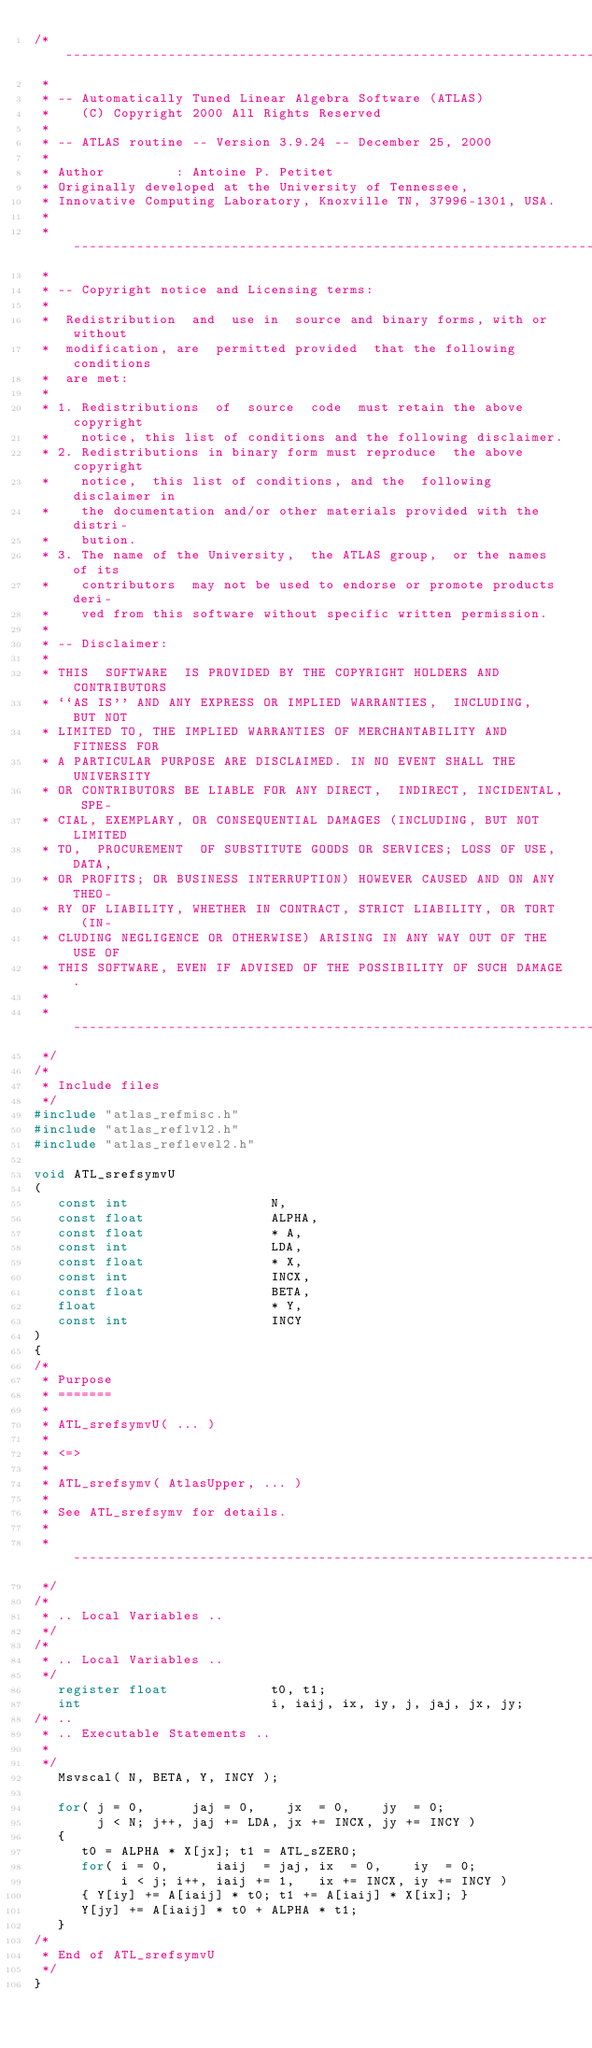Convert code to text. <code><loc_0><loc_0><loc_500><loc_500><_C_>/* ---------------------------------------------------------------------
 *
 * -- Automatically Tuned Linear Algebra Software (ATLAS)
 *    (C) Copyright 2000 All Rights Reserved
 *
 * -- ATLAS routine -- Version 3.9.24 -- December 25, 2000
 *
 * Author         : Antoine P. Petitet
 * Originally developed at the University of Tennessee,
 * Innovative Computing Laboratory, Knoxville TN, 37996-1301, USA.
 *
 * ---------------------------------------------------------------------
 *
 * -- Copyright notice and Licensing terms:
 *
 *  Redistribution  and  use in  source and binary forms, with or without
 *  modification, are  permitted provided  that the following  conditions
 *  are met:
 *
 * 1. Redistributions  of  source  code  must retain the above copyright
 *    notice, this list of conditions and the following disclaimer.
 * 2. Redistributions in binary form must reproduce  the above copyright
 *    notice,  this list of conditions, and the  following disclaimer in
 *    the documentation and/or other materials provided with the distri-
 *    bution.
 * 3. The name of the University,  the ATLAS group,  or the names of its
 *    contributors  may not be used to endorse or promote products deri-
 *    ved from this software without specific written permission.
 *
 * -- Disclaimer:
 *
 * THIS  SOFTWARE  IS PROVIDED BY THE COPYRIGHT HOLDERS AND CONTRIBUTORS
 * ``AS IS'' AND ANY EXPRESS OR IMPLIED WARRANTIES,  INCLUDING,  BUT NOT
 * LIMITED TO, THE IMPLIED WARRANTIES OF MERCHANTABILITY AND FITNESS FOR
 * A PARTICULAR PURPOSE ARE DISCLAIMED. IN NO EVENT SHALL THE UNIVERSITY
 * OR CONTRIBUTORS BE LIABLE FOR ANY DIRECT,  INDIRECT, INCIDENTAL, SPE-
 * CIAL, EXEMPLARY, OR CONSEQUENTIAL DAMAGES (INCLUDING, BUT NOT LIMITED
 * TO,  PROCUREMENT  OF SUBSTITUTE GOODS OR SERVICES; LOSS OF USE, DATA,
 * OR PROFITS; OR BUSINESS INTERRUPTION) HOWEVER CAUSED AND ON ANY THEO-
 * RY OF LIABILITY, WHETHER IN CONTRACT, STRICT LIABILITY, OR TORT  (IN-
 * CLUDING NEGLIGENCE OR OTHERWISE) ARISING IN ANY WAY OUT OF THE USE OF
 * THIS SOFTWARE, EVEN IF ADVISED OF THE POSSIBILITY OF SUCH DAMAGE.
 *
 * ---------------------------------------------------------------------
 */
/*
 * Include files
 */
#include "atlas_refmisc.h"
#include "atlas_reflvl2.h"
#include "atlas_reflevel2.h"

void ATL_srefsymvU
(
   const int                  N,
   const float                ALPHA,
   const float                * A,
   const int                  LDA,
   const float                * X,
   const int                  INCX,
   const float                BETA,
   float                      * Y,
   const int                  INCY
)
{
/*
 * Purpose
 * =======
 *
 * ATL_srefsymvU( ... )
 *
 * <=>
 *
 * ATL_srefsymv( AtlasUpper, ... )
 *
 * See ATL_srefsymv for details.
 *
 * ---------------------------------------------------------------------
 */
/*
 * .. Local Variables ..
 */
/*
 * .. Local Variables ..
 */
   register float             t0, t1;
   int                        i, iaij, ix, iy, j, jaj, jx, jy;
/* ..
 * .. Executable Statements ..
 *
 */
   Msvscal( N, BETA, Y, INCY );

   for( j = 0,      jaj = 0,    jx  = 0,    jy  = 0;
        j < N; j++, jaj += LDA, jx += INCX, jy += INCY )
   {
      t0 = ALPHA * X[jx]; t1 = ATL_sZERO;
      for( i = 0,      iaij  = jaj, ix  = 0,    iy  = 0;
           i < j; i++, iaij += 1,   ix += INCX, iy += INCY )
      { Y[iy] += A[iaij] * t0; t1 += A[iaij] * X[ix]; }
      Y[jy] += A[iaij] * t0 + ALPHA * t1;
   }
/*
 * End of ATL_srefsymvU
 */
}
</code> 